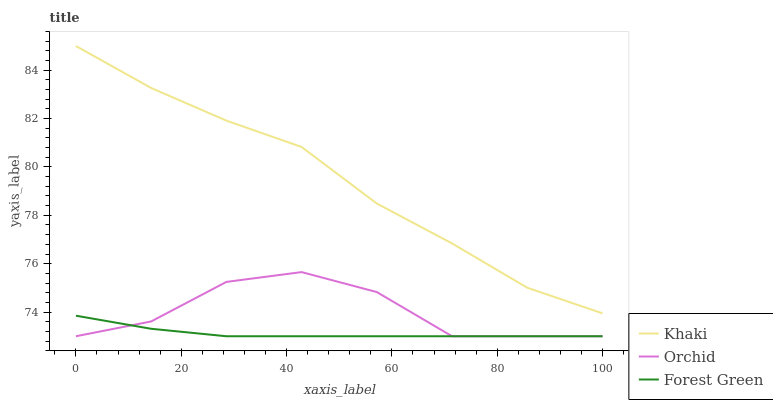Does Forest Green have the minimum area under the curve?
Answer yes or no. Yes. Does Khaki have the maximum area under the curve?
Answer yes or no. Yes. Does Orchid have the minimum area under the curve?
Answer yes or no. No. Does Orchid have the maximum area under the curve?
Answer yes or no. No. Is Forest Green the smoothest?
Answer yes or no. Yes. Is Orchid the roughest?
Answer yes or no. Yes. Is Khaki the smoothest?
Answer yes or no. No. Is Khaki the roughest?
Answer yes or no. No. Does Khaki have the lowest value?
Answer yes or no. No. Does Khaki have the highest value?
Answer yes or no. Yes. Does Orchid have the highest value?
Answer yes or no. No. Is Orchid less than Khaki?
Answer yes or no. Yes. Is Khaki greater than Forest Green?
Answer yes or no. Yes. Does Forest Green intersect Orchid?
Answer yes or no. Yes. Is Forest Green less than Orchid?
Answer yes or no. No. Is Forest Green greater than Orchid?
Answer yes or no. No. Does Orchid intersect Khaki?
Answer yes or no. No. 